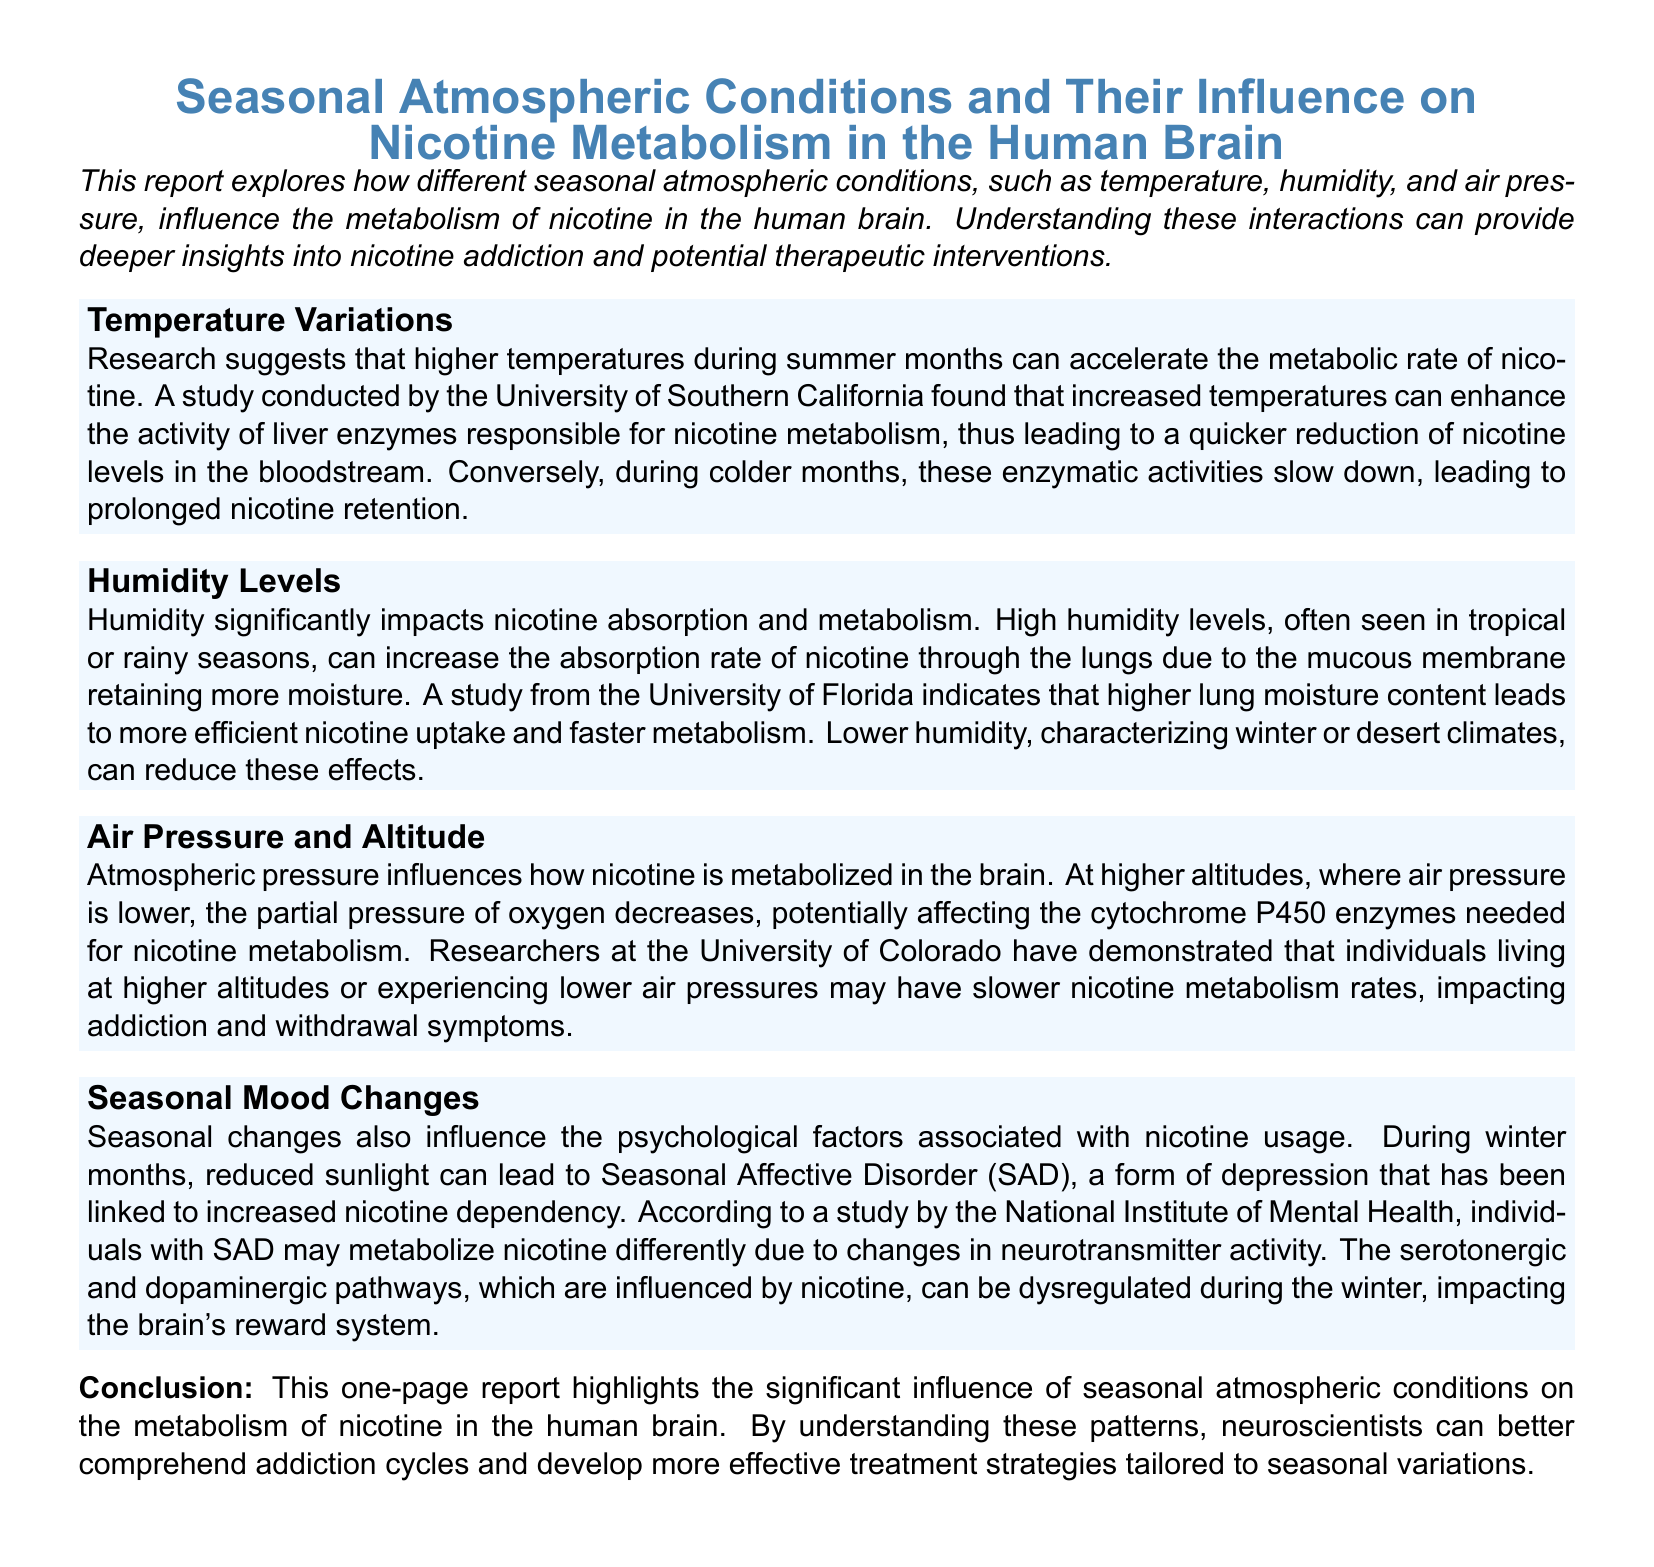What seasonal factor accelerates nicotine metabolism? The document states that higher temperatures during summer months can accelerate the metabolic rate of nicotine.
Answer: higher temperatures Which enzyme activity is enhanced by summer heat? The report mentions that increased temperatures can enhance the activity of liver enzymes responsible for nicotine metabolism.
Answer: liver enzymes What happens to nicotine retention in colder months? The document indicates that during colder months, enzymatic activities slow down, leading to prolonged nicotine retention.
Answer: prolonged nicotine retention How does humidity affect nicotine absorption? According to the document, high humidity levels can increase the absorption rate of nicotine through the lungs.
Answer: increase absorption rate What psychological condition is associated with increased nicotine dependency in winter? The report discusses Seasonal Affective Disorder (SAD) as a condition linked to increased nicotine dependency during the winter months.
Answer: Seasonal Affective Disorder (SAD) Which neurotransmitter pathways are influenced by nicotine during winter? The document refers to the serotonergic and dopaminergic pathways as being influenced by nicotine and potentially dysregulated during winter.
Answer: serotonergic and dopaminergic pathways What atmospheric condition impacts nicotine metabolism at higher altitudes? The document states that lower air pressure at higher altitudes affects the cytochrome P450 enzymes needed for nicotine metabolism.
Answer: lower air pressure What is the main focus of the report? The document focuses on how different seasonal atmospheric conditions influence nicotine metabolism in the human brain.
Answer: influence on nicotine metabolism Which institution conducted a study on humidity levels affecting nicotine? The document mentions a study conducted by the University of Florida regarding humidity levels and nicotine absorption.
Answer: University of Florida 